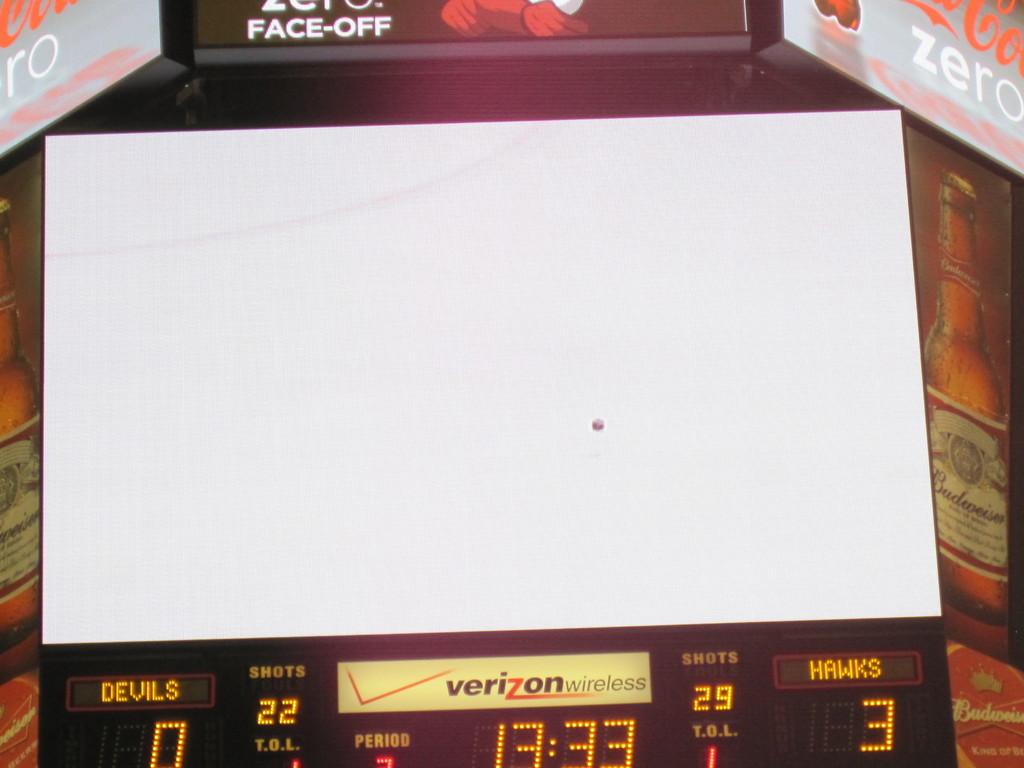How many points do the hawks have?
Offer a very short reply. 3. What is the score of the game?
Your answer should be compact. 0-3. 